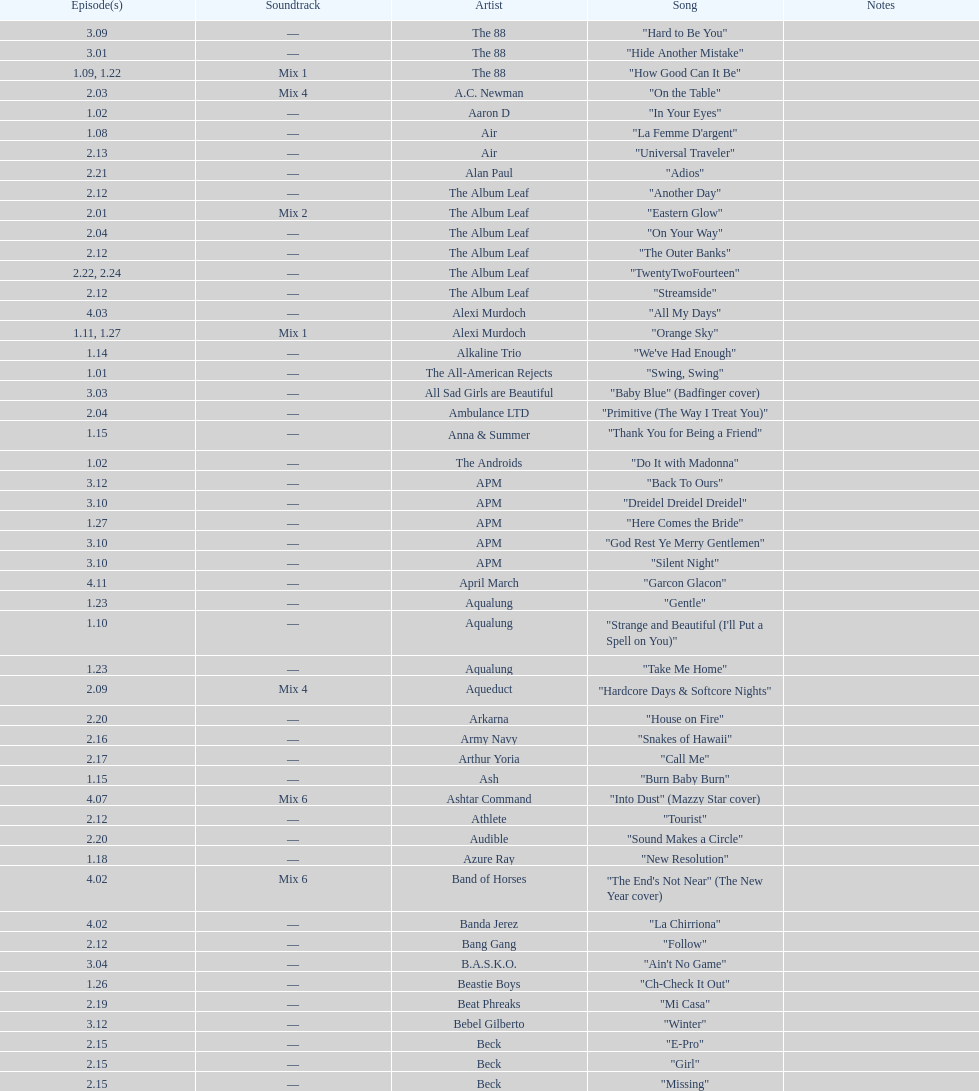How many consecutive songs were by the album leaf? 6. 